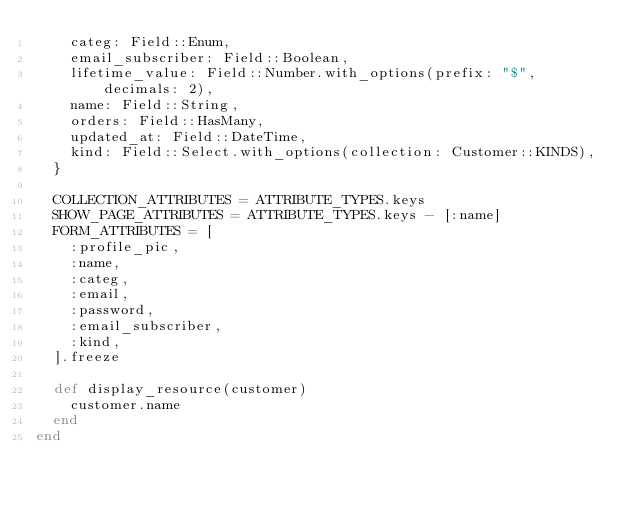<code> <loc_0><loc_0><loc_500><loc_500><_Ruby_>    categ: Field::Enum,
    email_subscriber: Field::Boolean,
    lifetime_value: Field::Number.with_options(prefix: "$", decimals: 2),
    name: Field::String,
    orders: Field::HasMany,
    updated_at: Field::DateTime,
    kind: Field::Select.with_options(collection: Customer::KINDS),
  }

  COLLECTION_ATTRIBUTES = ATTRIBUTE_TYPES.keys
  SHOW_PAGE_ATTRIBUTES = ATTRIBUTE_TYPES.keys - [:name]
  FORM_ATTRIBUTES = [
    :profile_pic,
    :name,
    :categ,
    :email,
    :password,
    :email_subscriber,
    :kind,
  ].freeze

  def display_resource(customer)
    customer.name
  end
end
</code> 